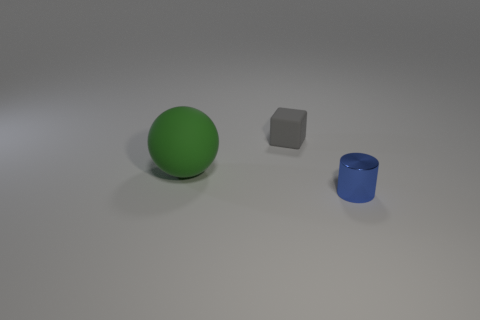Can you describe the textures of the objects shown? The green sphere and blue cylinder appear to have smooth, shiny surfaces, suggesting a metallic material, while the gray block looks like it has a matte finish, possibly plastic or stone. 